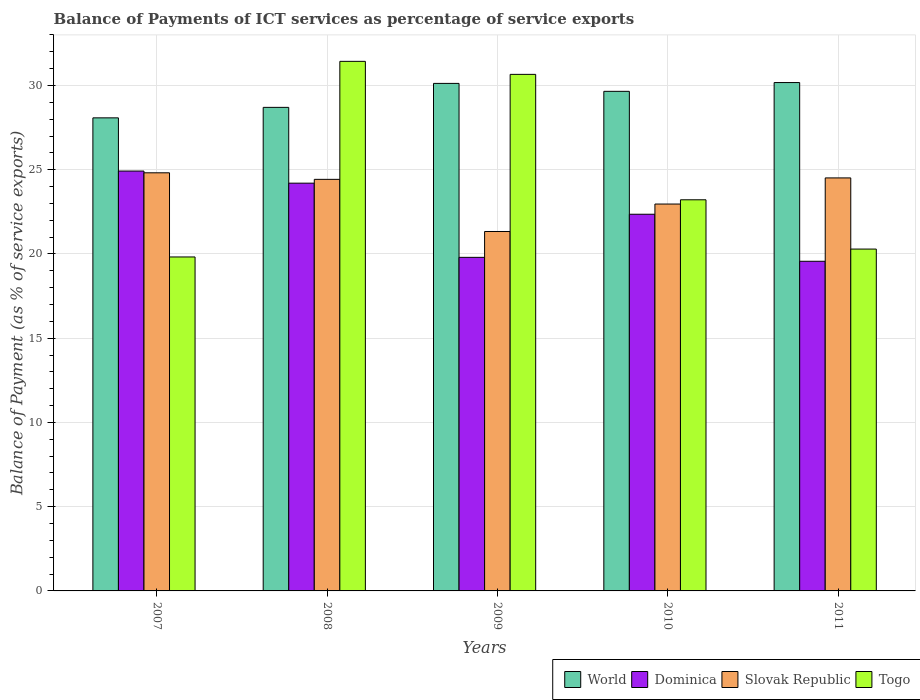How many different coloured bars are there?
Offer a terse response. 4. How many groups of bars are there?
Keep it short and to the point. 5. How many bars are there on the 4th tick from the left?
Make the answer very short. 4. How many bars are there on the 4th tick from the right?
Provide a short and direct response. 4. What is the label of the 4th group of bars from the left?
Keep it short and to the point. 2010. In how many cases, is the number of bars for a given year not equal to the number of legend labels?
Keep it short and to the point. 0. What is the balance of payments of ICT services in Slovak Republic in 2007?
Keep it short and to the point. 24.82. Across all years, what is the maximum balance of payments of ICT services in World?
Provide a succinct answer. 30.17. Across all years, what is the minimum balance of payments of ICT services in Togo?
Your response must be concise. 19.82. In which year was the balance of payments of ICT services in Togo maximum?
Your answer should be compact. 2008. In which year was the balance of payments of ICT services in Slovak Republic minimum?
Offer a terse response. 2009. What is the total balance of payments of ICT services in Dominica in the graph?
Your answer should be compact. 110.85. What is the difference between the balance of payments of ICT services in Dominica in 2008 and that in 2011?
Provide a short and direct response. 4.64. What is the difference between the balance of payments of ICT services in Dominica in 2008 and the balance of payments of ICT services in World in 2010?
Make the answer very short. -5.45. What is the average balance of payments of ICT services in World per year?
Your response must be concise. 29.35. In the year 2011, what is the difference between the balance of payments of ICT services in World and balance of payments of ICT services in Dominica?
Offer a terse response. 10.61. In how many years, is the balance of payments of ICT services in World greater than 3 %?
Give a very brief answer. 5. What is the ratio of the balance of payments of ICT services in Dominica in 2008 to that in 2009?
Make the answer very short. 1.22. What is the difference between the highest and the second highest balance of payments of ICT services in Togo?
Your response must be concise. 0.77. What is the difference between the highest and the lowest balance of payments of ICT services in World?
Make the answer very short. 2.09. Is it the case that in every year, the sum of the balance of payments of ICT services in Slovak Republic and balance of payments of ICT services in Dominica is greater than the sum of balance of payments of ICT services in World and balance of payments of ICT services in Togo?
Provide a succinct answer. No. What does the 4th bar from the left in 2011 represents?
Ensure brevity in your answer.  Togo. Is it the case that in every year, the sum of the balance of payments of ICT services in Dominica and balance of payments of ICT services in World is greater than the balance of payments of ICT services in Togo?
Provide a short and direct response. Yes. How many bars are there?
Offer a very short reply. 20. What is the difference between two consecutive major ticks on the Y-axis?
Your answer should be compact. 5. What is the title of the graph?
Your answer should be compact. Balance of Payments of ICT services as percentage of service exports. What is the label or title of the X-axis?
Keep it short and to the point. Years. What is the label or title of the Y-axis?
Your answer should be very brief. Balance of Payment (as % of service exports). What is the Balance of Payment (as % of service exports) of World in 2007?
Provide a short and direct response. 28.08. What is the Balance of Payment (as % of service exports) of Dominica in 2007?
Provide a succinct answer. 24.92. What is the Balance of Payment (as % of service exports) in Slovak Republic in 2007?
Ensure brevity in your answer.  24.82. What is the Balance of Payment (as % of service exports) of Togo in 2007?
Offer a terse response. 19.82. What is the Balance of Payment (as % of service exports) of World in 2008?
Make the answer very short. 28.7. What is the Balance of Payment (as % of service exports) of Dominica in 2008?
Your answer should be compact. 24.2. What is the Balance of Payment (as % of service exports) of Slovak Republic in 2008?
Give a very brief answer. 24.43. What is the Balance of Payment (as % of service exports) in Togo in 2008?
Your response must be concise. 31.43. What is the Balance of Payment (as % of service exports) in World in 2009?
Give a very brief answer. 30.13. What is the Balance of Payment (as % of service exports) of Dominica in 2009?
Offer a terse response. 19.8. What is the Balance of Payment (as % of service exports) of Slovak Republic in 2009?
Your response must be concise. 21.33. What is the Balance of Payment (as % of service exports) of Togo in 2009?
Your answer should be compact. 30.66. What is the Balance of Payment (as % of service exports) in World in 2010?
Keep it short and to the point. 29.65. What is the Balance of Payment (as % of service exports) in Dominica in 2010?
Your answer should be compact. 22.36. What is the Balance of Payment (as % of service exports) in Slovak Republic in 2010?
Ensure brevity in your answer.  22.96. What is the Balance of Payment (as % of service exports) in Togo in 2010?
Your answer should be compact. 23.22. What is the Balance of Payment (as % of service exports) of World in 2011?
Provide a succinct answer. 30.17. What is the Balance of Payment (as % of service exports) of Dominica in 2011?
Offer a very short reply. 19.57. What is the Balance of Payment (as % of service exports) of Slovak Republic in 2011?
Ensure brevity in your answer.  24.51. What is the Balance of Payment (as % of service exports) of Togo in 2011?
Ensure brevity in your answer.  20.29. Across all years, what is the maximum Balance of Payment (as % of service exports) in World?
Provide a succinct answer. 30.17. Across all years, what is the maximum Balance of Payment (as % of service exports) in Dominica?
Keep it short and to the point. 24.92. Across all years, what is the maximum Balance of Payment (as % of service exports) of Slovak Republic?
Your answer should be compact. 24.82. Across all years, what is the maximum Balance of Payment (as % of service exports) of Togo?
Your answer should be very brief. 31.43. Across all years, what is the minimum Balance of Payment (as % of service exports) of World?
Make the answer very short. 28.08. Across all years, what is the minimum Balance of Payment (as % of service exports) in Dominica?
Give a very brief answer. 19.57. Across all years, what is the minimum Balance of Payment (as % of service exports) in Slovak Republic?
Your response must be concise. 21.33. Across all years, what is the minimum Balance of Payment (as % of service exports) of Togo?
Keep it short and to the point. 19.82. What is the total Balance of Payment (as % of service exports) of World in the graph?
Your response must be concise. 146.74. What is the total Balance of Payment (as % of service exports) of Dominica in the graph?
Your answer should be compact. 110.85. What is the total Balance of Payment (as % of service exports) of Slovak Republic in the graph?
Your answer should be very brief. 118.06. What is the total Balance of Payment (as % of service exports) in Togo in the graph?
Ensure brevity in your answer.  125.43. What is the difference between the Balance of Payment (as % of service exports) in World in 2007 and that in 2008?
Ensure brevity in your answer.  -0.62. What is the difference between the Balance of Payment (as % of service exports) in Dominica in 2007 and that in 2008?
Give a very brief answer. 0.72. What is the difference between the Balance of Payment (as % of service exports) in Slovak Republic in 2007 and that in 2008?
Your answer should be compact. 0.39. What is the difference between the Balance of Payment (as % of service exports) of Togo in 2007 and that in 2008?
Give a very brief answer. -11.61. What is the difference between the Balance of Payment (as % of service exports) in World in 2007 and that in 2009?
Give a very brief answer. -2.05. What is the difference between the Balance of Payment (as % of service exports) in Dominica in 2007 and that in 2009?
Your answer should be very brief. 5.12. What is the difference between the Balance of Payment (as % of service exports) in Slovak Republic in 2007 and that in 2009?
Offer a very short reply. 3.48. What is the difference between the Balance of Payment (as % of service exports) of Togo in 2007 and that in 2009?
Provide a succinct answer. -10.84. What is the difference between the Balance of Payment (as % of service exports) of World in 2007 and that in 2010?
Provide a succinct answer. -1.57. What is the difference between the Balance of Payment (as % of service exports) of Dominica in 2007 and that in 2010?
Your answer should be compact. 2.56. What is the difference between the Balance of Payment (as % of service exports) of Slovak Republic in 2007 and that in 2010?
Provide a succinct answer. 1.85. What is the difference between the Balance of Payment (as % of service exports) of Togo in 2007 and that in 2010?
Your answer should be very brief. -3.39. What is the difference between the Balance of Payment (as % of service exports) in World in 2007 and that in 2011?
Keep it short and to the point. -2.09. What is the difference between the Balance of Payment (as % of service exports) in Dominica in 2007 and that in 2011?
Give a very brief answer. 5.36. What is the difference between the Balance of Payment (as % of service exports) of Slovak Republic in 2007 and that in 2011?
Ensure brevity in your answer.  0.3. What is the difference between the Balance of Payment (as % of service exports) in Togo in 2007 and that in 2011?
Give a very brief answer. -0.47. What is the difference between the Balance of Payment (as % of service exports) of World in 2008 and that in 2009?
Ensure brevity in your answer.  -1.42. What is the difference between the Balance of Payment (as % of service exports) in Dominica in 2008 and that in 2009?
Your response must be concise. 4.4. What is the difference between the Balance of Payment (as % of service exports) of Slovak Republic in 2008 and that in 2009?
Ensure brevity in your answer.  3.09. What is the difference between the Balance of Payment (as % of service exports) of Togo in 2008 and that in 2009?
Make the answer very short. 0.77. What is the difference between the Balance of Payment (as % of service exports) of World in 2008 and that in 2010?
Your answer should be compact. -0.95. What is the difference between the Balance of Payment (as % of service exports) of Dominica in 2008 and that in 2010?
Your response must be concise. 1.84. What is the difference between the Balance of Payment (as % of service exports) in Slovak Republic in 2008 and that in 2010?
Your response must be concise. 1.47. What is the difference between the Balance of Payment (as % of service exports) of Togo in 2008 and that in 2010?
Keep it short and to the point. 8.22. What is the difference between the Balance of Payment (as % of service exports) in World in 2008 and that in 2011?
Keep it short and to the point. -1.47. What is the difference between the Balance of Payment (as % of service exports) of Dominica in 2008 and that in 2011?
Your answer should be compact. 4.64. What is the difference between the Balance of Payment (as % of service exports) in Slovak Republic in 2008 and that in 2011?
Offer a very short reply. -0.09. What is the difference between the Balance of Payment (as % of service exports) in Togo in 2008 and that in 2011?
Keep it short and to the point. 11.14. What is the difference between the Balance of Payment (as % of service exports) of World in 2009 and that in 2010?
Your response must be concise. 0.47. What is the difference between the Balance of Payment (as % of service exports) in Dominica in 2009 and that in 2010?
Offer a very short reply. -2.56. What is the difference between the Balance of Payment (as % of service exports) in Slovak Republic in 2009 and that in 2010?
Your response must be concise. -1.63. What is the difference between the Balance of Payment (as % of service exports) in Togo in 2009 and that in 2010?
Your answer should be compact. 7.44. What is the difference between the Balance of Payment (as % of service exports) of World in 2009 and that in 2011?
Offer a very short reply. -0.05. What is the difference between the Balance of Payment (as % of service exports) in Dominica in 2009 and that in 2011?
Ensure brevity in your answer.  0.23. What is the difference between the Balance of Payment (as % of service exports) in Slovak Republic in 2009 and that in 2011?
Ensure brevity in your answer.  -3.18. What is the difference between the Balance of Payment (as % of service exports) of Togo in 2009 and that in 2011?
Make the answer very short. 10.37. What is the difference between the Balance of Payment (as % of service exports) of World in 2010 and that in 2011?
Ensure brevity in your answer.  -0.52. What is the difference between the Balance of Payment (as % of service exports) in Dominica in 2010 and that in 2011?
Give a very brief answer. 2.79. What is the difference between the Balance of Payment (as % of service exports) of Slovak Republic in 2010 and that in 2011?
Offer a terse response. -1.55. What is the difference between the Balance of Payment (as % of service exports) in Togo in 2010 and that in 2011?
Make the answer very short. 2.92. What is the difference between the Balance of Payment (as % of service exports) in World in 2007 and the Balance of Payment (as % of service exports) in Dominica in 2008?
Offer a very short reply. 3.88. What is the difference between the Balance of Payment (as % of service exports) in World in 2007 and the Balance of Payment (as % of service exports) in Slovak Republic in 2008?
Your answer should be compact. 3.65. What is the difference between the Balance of Payment (as % of service exports) in World in 2007 and the Balance of Payment (as % of service exports) in Togo in 2008?
Your answer should be compact. -3.35. What is the difference between the Balance of Payment (as % of service exports) of Dominica in 2007 and the Balance of Payment (as % of service exports) of Slovak Republic in 2008?
Ensure brevity in your answer.  0.49. What is the difference between the Balance of Payment (as % of service exports) in Dominica in 2007 and the Balance of Payment (as % of service exports) in Togo in 2008?
Keep it short and to the point. -6.51. What is the difference between the Balance of Payment (as % of service exports) in Slovak Republic in 2007 and the Balance of Payment (as % of service exports) in Togo in 2008?
Make the answer very short. -6.62. What is the difference between the Balance of Payment (as % of service exports) in World in 2007 and the Balance of Payment (as % of service exports) in Dominica in 2009?
Provide a succinct answer. 8.28. What is the difference between the Balance of Payment (as % of service exports) of World in 2007 and the Balance of Payment (as % of service exports) of Slovak Republic in 2009?
Your answer should be compact. 6.75. What is the difference between the Balance of Payment (as % of service exports) in World in 2007 and the Balance of Payment (as % of service exports) in Togo in 2009?
Provide a short and direct response. -2.58. What is the difference between the Balance of Payment (as % of service exports) of Dominica in 2007 and the Balance of Payment (as % of service exports) of Slovak Republic in 2009?
Provide a succinct answer. 3.59. What is the difference between the Balance of Payment (as % of service exports) in Dominica in 2007 and the Balance of Payment (as % of service exports) in Togo in 2009?
Make the answer very short. -5.74. What is the difference between the Balance of Payment (as % of service exports) in Slovak Republic in 2007 and the Balance of Payment (as % of service exports) in Togo in 2009?
Your answer should be compact. -5.84. What is the difference between the Balance of Payment (as % of service exports) in World in 2007 and the Balance of Payment (as % of service exports) in Dominica in 2010?
Provide a succinct answer. 5.72. What is the difference between the Balance of Payment (as % of service exports) in World in 2007 and the Balance of Payment (as % of service exports) in Slovak Republic in 2010?
Your response must be concise. 5.12. What is the difference between the Balance of Payment (as % of service exports) of World in 2007 and the Balance of Payment (as % of service exports) of Togo in 2010?
Provide a succinct answer. 4.86. What is the difference between the Balance of Payment (as % of service exports) in Dominica in 2007 and the Balance of Payment (as % of service exports) in Slovak Republic in 2010?
Offer a very short reply. 1.96. What is the difference between the Balance of Payment (as % of service exports) of Dominica in 2007 and the Balance of Payment (as % of service exports) of Togo in 2010?
Your answer should be compact. 1.71. What is the difference between the Balance of Payment (as % of service exports) in Slovak Republic in 2007 and the Balance of Payment (as % of service exports) in Togo in 2010?
Your answer should be very brief. 1.6. What is the difference between the Balance of Payment (as % of service exports) of World in 2007 and the Balance of Payment (as % of service exports) of Dominica in 2011?
Give a very brief answer. 8.51. What is the difference between the Balance of Payment (as % of service exports) in World in 2007 and the Balance of Payment (as % of service exports) in Slovak Republic in 2011?
Keep it short and to the point. 3.57. What is the difference between the Balance of Payment (as % of service exports) in World in 2007 and the Balance of Payment (as % of service exports) in Togo in 2011?
Ensure brevity in your answer.  7.79. What is the difference between the Balance of Payment (as % of service exports) of Dominica in 2007 and the Balance of Payment (as % of service exports) of Slovak Republic in 2011?
Provide a short and direct response. 0.41. What is the difference between the Balance of Payment (as % of service exports) of Dominica in 2007 and the Balance of Payment (as % of service exports) of Togo in 2011?
Your response must be concise. 4.63. What is the difference between the Balance of Payment (as % of service exports) of Slovak Republic in 2007 and the Balance of Payment (as % of service exports) of Togo in 2011?
Provide a succinct answer. 4.53. What is the difference between the Balance of Payment (as % of service exports) of World in 2008 and the Balance of Payment (as % of service exports) of Dominica in 2009?
Give a very brief answer. 8.9. What is the difference between the Balance of Payment (as % of service exports) of World in 2008 and the Balance of Payment (as % of service exports) of Slovak Republic in 2009?
Your answer should be very brief. 7.37. What is the difference between the Balance of Payment (as % of service exports) of World in 2008 and the Balance of Payment (as % of service exports) of Togo in 2009?
Your response must be concise. -1.96. What is the difference between the Balance of Payment (as % of service exports) of Dominica in 2008 and the Balance of Payment (as % of service exports) of Slovak Republic in 2009?
Keep it short and to the point. 2.87. What is the difference between the Balance of Payment (as % of service exports) in Dominica in 2008 and the Balance of Payment (as % of service exports) in Togo in 2009?
Ensure brevity in your answer.  -6.46. What is the difference between the Balance of Payment (as % of service exports) in Slovak Republic in 2008 and the Balance of Payment (as % of service exports) in Togo in 2009?
Make the answer very short. -6.23. What is the difference between the Balance of Payment (as % of service exports) in World in 2008 and the Balance of Payment (as % of service exports) in Dominica in 2010?
Give a very brief answer. 6.34. What is the difference between the Balance of Payment (as % of service exports) of World in 2008 and the Balance of Payment (as % of service exports) of Slovak Republic in 2010?
Your answer should be very brief. 5.74. What is the difference between the Balance of Payment (as % of service exports) in World in 2008 and the Balance of Payment (as % of service exports) in Togo in 2010?
Your answer should be very brief. 5.49. What is the difference between the Balance of Payment (as % of service exports) in Dominica in 2008 and the Balance of Payment (as % of service exports) in Slovak Republic in 2010?
Offer a very short reply. 1.24. What is the difference between the Balance of Payment (as % of service exports) of Dominica in 2008 and the Balance of Payment (as % of service exports) of Togo in 2010?
Your answer should be compact. 0.99. What is the difference between the Balance of Payment (as % of service exports) in Slovak Republic in 2008 and the Balance of Payment (as % of service exports) in Togo in 2010?
Make the answer very short. 1.21. What is the difference between the Balance of Payment (as % of service exports) in World in 2008 and the Balance of Payment (as % of service exports) in Dominica in 2011?
Your response must be concise. 9.14. What is the difference between the Balance of Payment (as % of service exports) in World in 2008 and the Balance of Payment (as % of service exports) in Slovak Republic in 2011?
Ensure brevity in your answer.  4.19. What is the difference between the Balance of Payment (as % of service exports) of World in 2008 and the Balance of Payment (as % of service exports) of Togo in 2011?
Provide a short and direct response. 8.41. What is the difference between the Balance of Payment (as % of service exports) of Dominica in 2008 and the Balance of Payment (as % of service exports) of Slovak Republic in 2011?
Provide a succinct answer. -0.31. What is the difference between the Balance of Payment (as % of service exports) in Dominica in 2008 and the Balance of Payment (as % of service exports) in Togo in 2011?
Give a very brief answer. 3.91. What is the difference between the Balance of Payment (as % of service exports) in Slovak Republic in 2008 and the Balance of Payment (as % of service exports) in Togo in 2011?
Keep it short and to the point. 4.14. What is the difference between the Balance of Payment (as % of service exports) in World in 2009 and the Balance of Payment (as % of service exports) in Dominica in 2010?
Your answer should be compact. 7.77. What is the difference between the Balance of Payment (as % of service exports) of World in 2009 and the Balance of Payment (as % of service exports) of Slovak Republic in 2010?
Keep it short and to the point. 7.16. What is the difference between the Balance of Payment (as % of service exports) of World in 2009 and the Balance of Payment (as % of service exports) of Togo in 2010?
Provide a succinct answer. 6.91. What is the difference between the Balance of Payment (as % of service exports) of Dominica in 2009 and the Balance of Payment (as % of service exports) of Slovak Republic in 2010?
Your response must be concise. -3.16. What is the difference between the Balance of Payment (as % of service exports) of Dominica in 2009 and the Balance of Payment (as % of service exports) of Togo in 2010?
Make the answer very short. -3.42. What is the difference between the Balance of Payment (as % of service exports) of Slovak Republic in 2009 and the Balance of Payment (as % of service exports) of Togo in 2010?
Your answer should be very brief. -1.88. What is the difference between the Balance of Payment (as % of service exports) in World in 2009 and the Balance of Payment (as % of service exports) in Dominica in 2011?
Offer a terse response. 10.56. What is the difference between the Balance of Payment (as % of service exports) of World in 2009 and the Balance of Payment (as % of service exports) of Slovak Republic in 2011?
Your answer should be compact. 5.61. What is the difference between the Balance of Payment (as % of service exports) of World in 2009 and the Balance of Payment (as % of service exports) of Togo in 2011?
Offer a terse response. 9.83. What is the difference between the Balance of Payment (as % of service exports) in Dominica in 2009 and the Balance of Payment (as % of service exports) in Slovak Republic in 2011?
Your response must be concise. -4.72. What is the difference between the Balance of Payment (as % of service exports) in Dominica in 2009 and the Balance of Payment (as % of service exports) in Togo in 2011?
Keep it short and to the point. -0.49. What is the difference between the Balance of Payment (as % of service exports) of Slovak Republic in 2009 and the Balance of Payment (as % of service exports) of Togo in 2011?
Your response must be concise. 1.04. What is the difference between the Balance of Payment (as % of service exports) of World in 2010 and the Balance of Payment (as % of service exports) of Dominica in 2011?
Make the answer very short. 10.09. What is the difference between the Balance of Payment (as % of service exports) of World in 2010 and the Balance of Payment (as % of service exports) of Slovak Republic in 2011?
Your answer should be very brief. 5.14. What is the difference between the Balance of Payment (as % of service exports) in World in 2010 and the Balance of Payment (as % of service exports) in Togo in 2011?
Ensure brevity in your answer.  9.36. What is the difference between the Balance of Payment (as % of service exports) of Dominica in 2010 and the Balance of Payment (as % of service exports) of Slovak Republic in 2011?
Provide a short and direct response. -2.16. What is the difference between the Balance of Payment (as % of service exports) of Dominica in 2010 and the Balance of Payment (as % of service exports) of Togo in 2011?
Make the answer very short. 2.07. What is the difference between the Balance of Payment (as % of service exports) of Slovak Republic in 2010 and the Balance of Payment (as % of service exports) of Togo in 2011?
Your answer should be compact. 2.67. What is the average Balance of Payment (as % of service exports) of World per year?
Ensure brevity in your answer.  29.35. What is the average Balance of Payment (as % of service exports) in Dominica per year?
Your answer should be compact. 22.17. What is the average Balance of Payment (as % of service exports) of Slovak Republic per year?
Provide a succinct answer. 23.61. What is the average Balance of Payment (as % of service exports) in Togo per year?
Your answer should be compact. 25.09. In the year 2007, what is the difference between the Balance of Payment (as % of service exports) in World and Balance of Payment (as % of service exports) in Dominica?
Make the answer very short. 3.16. In the year 2007, what is the difference between the Balance of Payment (as % of service exports) in World and Balance of Payment (as % of service exports) in Slovak Republic?
Offer a terse response. 3.26. In the year 2007, what is the difference between the Balance of Payment (as % of service exports) in World and Balance of Payment (as % of service exports) in Togo?
Ensure brevity in your answer.  8.26. In the year 2007, what is the difference between the Balance of Payment (as % of service exports) in Dominica and Balance of Payment (as % of service exports) in Slovak Republic?
Offer a very short reply. 0.1. In the year 2007, what is the difference between the Balance of Payment (as % of service exports) of Dominica and Balance of Payment (as % of service exports) of Togo?
Make the answer very short. 5.1. In the year 2007, what is the difference between the Balance of Payment (as % of service exports) of Slovak Republic and Balance of Payment (as % of service exports) of Togo?
Offer a very short reply. 5. In the year 2008, what is the difference between the Balance of Payment (as % of service exports) in World and Balance of Payment (as % of service exports) in Dominica?
Your answer should be very brief. 4.5. In the year 2008, what is the difference between the Balance of Payment (as % of service exports) of World and Balance of Payment (as % of service exports) of Slovak Republic?
Provide a succinct answer. 4.27. In the year 2008, what is the difference between the Balance of Payment (as % of service exports) in World and Balance of Payment (as % of service exports) in Togo?
Your answer should be compact. -2.73. In the year 2008, what is the difference between the Balance of Payment (as % of service exports) in Dominica and Balance of Payment (as % of service exports) in Slovak Republic?
Your response must be concise. -0.23. In the year 2008, what is the difference between the Balance of Payment (as % of service exports) of Dominica and Balance of Payment (as % of service exports) of Togo?
Offer a terse response. -7.23. In the year 2008, what is the difference between the Balance of Payment (as % of service exports) in Slovak Republic and Balance of Payment (as % of service exports) in Togo?
Your answer should be very brief. -7. In the year 2009, what is the difference between the Balance of Payment (as % of service exports) in World and Balance of Payment (as % of service exports) in Dominica?
Your response must be concise. 10.33. In the year 2009, what is the difference between the Balance of Payment (as % of service exports) in World and Balance of Payment (as % of service exports) in Slovak Republic?
Keep it short and to the point. 8.79. In the year 2009, what is the difference between the Balance of Payment (as % of service exports) of World and Balance of Payment (as % of service exports) of Togo?
Keep it short and to the point. -0.54. In the year 2009, what is the difference between the Balance of Payment (as % of service exports) in Dominica and Balance of Payment (as % of service exports) in Slovak Republic?
Offer a very short reply. -1.53. In the year 2009, what is the difference between the Balance of Payment (as % of service exports) in Dominica and Balance of Payment (as % of service exports) in Togo?
Your answer should be very brief. -10.86. In the year 2009, what is the difference between the Balance of Payment (as % of service exports) of Slovak Republic and Balance of Payment (as % of service exports) of Togo?
Give a very brief answer. -9.33. In the year 2010, what is the difference between the Balance of Payment (as % of service exports) of World and Balance of Payment (as % of service exports) of Dominica?
Offer a very short reply. 7.3. In the year 2010, what is the difference between the Balance of Payment (as % of service exports) in World and Balance of Payment (as % of service exports) in Slovak Republic?
Give a very brief answer. 6.69. In the year 2010, what is the difference between the Balance of Payment (as % of service exports) in World and Balance of Payment (as % of service exports) in Togo?
Your answer should be compact. 6.44. In the year 2010, what is the difference between the Balance of Payment (as % of service exports) of Dominica and Balance of Payment (as % of service exports) of Slovak Republic?
Your response must be concise. -0.61. In the year 2010, what is the difference between the Balance of Payment (as % of service exports) in Dominica and Balance of Payment (as % of service exports) in Togo?
Provide a succinct answer. -0.86. In the year 2010, what is the difference between the Balance of Payment (as % of service exports) in Slovak Republic and Balance of Payment (as % of service exports) in Togo?
Offer a terse response. -0.25. In the year 2011, what is the difference between the Balance of Payment (as % of service exports) of World and Balance of Payment (as % of service exports) of Dominica?
Ensure brevity in your answer.  10.61. In the year 2011, what is the difference between the Balance of Payment (as % of service exports) of World and Balance of Payment (as % of service exports) of Slovak Republic?
Keep it short and to the point. 5.66. In the year 2011, what is the difference between the Balance of Payment (as % of service exports) of World and Balance of Payment (as % of service exports) of Togo?
Offer a terse response. 9.88. In the year 2011, what is the difference between the Balance of Payment (as % of service exports) of Dominica and Balance of Payment (as % of service exports) of Slovak Republic?
Offer a very short reply. -4.95. In the year 2011, what is the difference between the Balance of Payment (as % of service exports) of Dominica and Balance of Payment (as % of service exports) of Togo?
Provide a succinct answer. -0.72. In the year 2011, what is the difference between the Balance of Payment (as % of service exports) of Slovak Republic and Balance of Payment (as % of service exports) of Togo?
Provide a succinct answer. 4.22. What is the ratio of the Balance of Payment (as % of service exports) of World in 2007 to that in 2008?
Offer a terse response. 0.98. What is the ratio of the Balance of Payment (as % of service exports) of Dominica in 2007 to that in 2008?
Offer a very short reply. 1.03. What is the ratio of the Balance of Payment (as % of service exports) in Slovak Republic in 2007 to that in 2008?
Keep it short and to the point. 1.02. What is the ratio of the Balance of Payment (as % of service exports) in Togo in 2007 to that in 2008?
Provide a short and direct response. 0.63. What is the ratio of the Balance of Payment (as % of service exports) of World in 2007 to that in 2009?
Provide a short and direct response. 0.93. What is the ratio of the Balance of Payment (as % of service exports) of Dominica in 2007 to that in 2009?
Your answer should be very brief. 1.26. What is the ratio of the Balance of Payment (as % of service exports) of Slovak Republic in 2007 to that in 2009?
Offer a very short reply. 1.16. What is the ratio of the Balance of Payment (as % of service exports) in Togo in 2007 to that in 2009?
Offer a very short reply. 0.65. What is the ratio of the Balance of Payment (as % of service exports) in World in 2007 to that in 2010?
Provide a succinct answer. 0.95. What is the ratio of the Balance of Payment (as % of service exports) of Dominica in 2007 to that in 2010?
Your response must be concise. 1.11. What is the ratio of the Balance of Payment (as % of service exports) of Slovak Republic in 2007 to that in 2010?
Offer a terse response. 1.08. What is the ratio of the Balance of Payment (as % of service exports) of Togo in 2007 to that in 2010?
Keep it short and to the point. 0.85. What is the ratio of the Balance of Payment (as % of service exports) in World in 2007 to that in 2011?
Keep it short and to the point. 0.93. What is the ratio of the Balance of Payment (as % of service exports) in Dominica in 2007 to that in 2011?
Provide a succinct answer. 1.27. What is the ratio of the Balance of Payment (as % of service exports) in Slovak Republic in 2007 to that in 2011?
Give a very brief answer. 1.01. What is the ratio of the Balance of Payment (as % of service exports) in Togo in 2007 to that in 2011?
Provide a succinct answer. 0.98. What is the ratio of the Balance of Payment (as % of service exports) in World in 2008 to that in 2009?
Your answer should be compact. 0.95. What is the ratio of the Balance of Payment (as % of service exports) in Dominica in 2008 to that in 2009?
Your answer should be very brief. 1.22. What is the ratio of the Balance of Payment (as % of service exports) in Slovak Republic in 2008 to that in 2009?
Give a very brief answer. 1.15. What is the ratio of the Balance of Payment (as % of service exports) of Togo in 2008 to that in 2009?
Provide a short and direct response. 1.03. What is the ratio of the Balance of Payment (as % of service exports) of World in 2008 to that in 2010?
Provide a short and direct response. 0.97. What is the ratio of the Balance of Payment (as % of service exports) in Dominica in 2008 to that in 2010?
Offer a terse response. 1.08. What is the ratio of the Balance of Payment (as % of service exports) of Slovak Republic in 2008 to that in 2010?
Provide a short and direct response. 1.06. What is the ratio of the Balance of Payment (as % of service exports) of Togo in 2008 to that in 2010?
Your response must be concise. 1.35. What is the ratio of the Balance of Payment (as % of service exports) of World in 2008 to that in 2011?
Give a very brief answer. 0.95. What is the ratio of the Balance of Payment (as % of service exports) in Dominica in 2008 to that in 2011?
Offer a terse response. 1.24. What is the ratio of the Balance of Payment (as % of service exports) in Slovak Republic in 2008 to that in 2011?
Your answer should be very brief. 1. What is the ratio of the Balance of Payment (as % of service exports) of Togo in 2008 to that in 2011?
Make the answer very short. 1.55. What is the ratio of the Balance of Payment (as % of service exports) of World in 2009 to that in 2010?
Ensure brevity in your answer.  1.02. What is the ratio of the Balance of Payment (as % of service exports) of Dominica in 2009 to that in 2010?
Provide a succinct answer. 0.89. What is the ratio of the Balance of Payment (as % of service exports) in Slovak Republic in 2009 to that in 2010?
Ensure brevity in your answer.  0.93. What is the ratio of the Balance of Payment (as % of service exports) of Togo in 2009 to that in 2010?
Offer a very short reply. 1.32. What is the ratio of the Balance of Payment (as % of service exports) of Dominica in 2009 to that in 2011?
Make the answer very short. 1.01. What is the ratio of the Balance of Payment (as % of service exports) of Slovak Republic in 2009 to that in 2011?
Your answer should be very brief. 0.87. What is the ratio of the Balance of Payment (as % of service exports) in Togo in 2009 to that in 2011?
Ensure brevity in your answer.  1.51. What is the ratio of the Balance of Payment (as % of service exports) of World in 2010 to that in 2011?
Keep it short and to the point. 0.98. What is the ratio of the Balance of Payment (as % of service exports) in Dominica in 2010 to that in 2011?
Your response must be concise. 1.14. What is the ratio of the Balance of Payment (as % of service exports) in Slovak Republic in 2010 to that in 2011?
Give a very brief answer. 0.94. What is the ratio of the Balance of Payment (as % of service exports) in Togo in 2010 to that in 2011?
Keep it short and to the point. 1.14. What is the difference between the highest and the second highest Balance of Payment (as % of service exports) in World?
Offer a very short reply. 0.05. What is the difference between the highest and the second highest Balance of Payment (as % of service exports) of Dominica?
Offer a terse response. 0.72. What is the difference between the highest and the second highest Balance of Payment (as % of service exports) in Slovak Republic?
Provide a short and direct response. 0.3. What is the difference between the highest and the second highest Balance of Payment (as % of service exports) in Togo?
Offer a very short reply. 0.77. What is the difference between the highest and the lowest Balance of Payment (as % of service exports) of World?
Offer a very short reply. 2.09. What is the difference between the highest and the lowest Balance of Payment (as % of service exports) of Dominica?
Give a very brief answer. 5.36. What is the difference between the highest and the lowest Balance of Payment (as % of service exports) in Slovak Republic?
Ensure brevity in your answer.  3.48. What is the difference between the highest and the lowest Balance of Payment (as % of service exports) of Togo?
Provide a short and direct response. 11.61. 